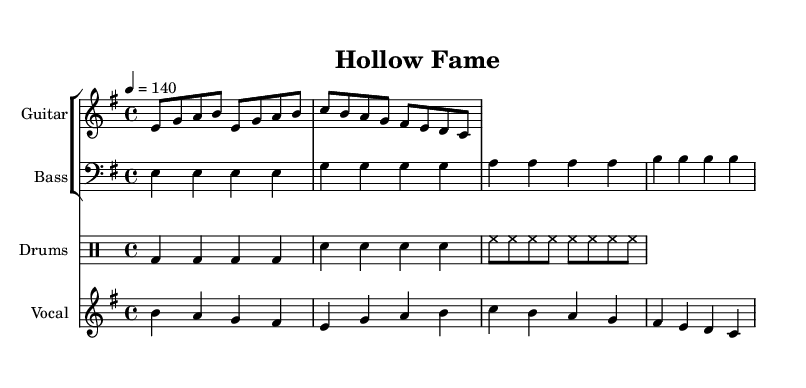What is the key signature of this music? The key signature is E minor, indicated by one sharp (F#). This can be determined by examining the key signature markings at the beginning of the staff.
Answer: E minor What is the time signature of this music? The time signature is 4/4, which means there are four beats in each measure and the quarter note gets one beat. This is visible in the time signature marking at the beginning of the score.
Answer: 4/4 What is the tempo marking for this music? The tempo marking is quarter note equals 140 beats per minute. This is indicated in the score, providing the speed at which the piece should be played.
Answer: 140 How many measures are in the guitar riff? The guitar riff consists of four measures, which can be counted by observing the notation of the notes grouped into four repetitive sections.
Answer: Four What is the primary theme reflected in the lyrics? The primary theme in the lyrics critiques the emptiness of chasing fame and its impact on individuals, indicated by phrases such as "empty souls" and "chasing fame that takes its toll."
Answer: Emptiness of fame How does the vocal melody relate to the guitar riff? The vocal melody harmonizes with the guitar riff, primarily utilizing the same pitches and rhythms, creating a consistent blend of sound throughout the section. This can be observed by comparing note values and pitches between both parts.
Answer: Harmonizes What type of drum pattern is used in this song? The drum pattern primarily utilizes a standard rock beat, featuring bass and snare hits with consistent hi-hat play, which is typical in traditional heavy metal tracks. This can be determined by analyzing the rhythmic layout in the drum staff.
Answer: Standard rock beat 